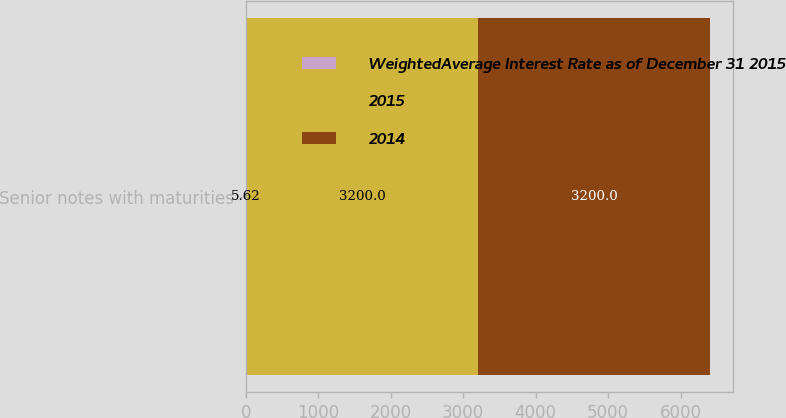Convert chart. <chart><loc_0><loc_0><loc_500><loc_500><stacked_bar_chart><ecel><fcel>Senior notes with maturities<nl><fcel>WeightedAverage Interest Rate as of December 31 2015<fcel>5.62<nl><fcel>2015<fcel>3200<nl><fcel>2014<fcel>3200<nl></chart> 